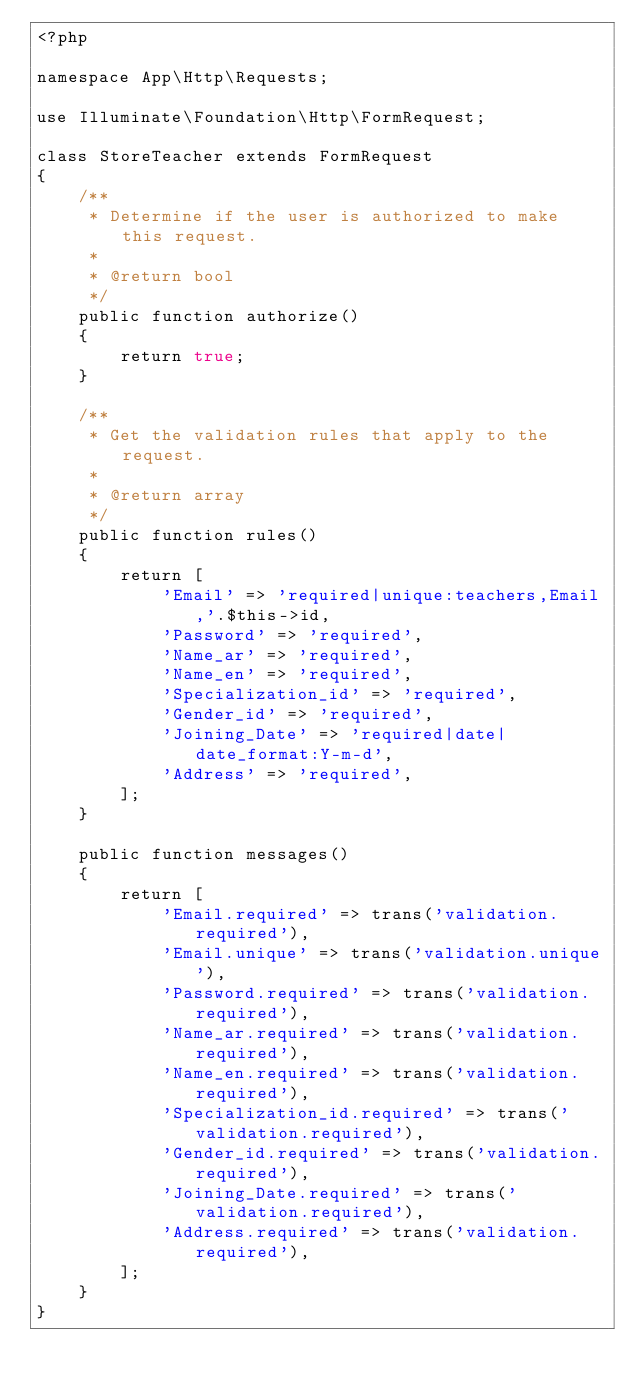Convert code to text. <code><loc_0><loc_0><loc_500><loc_500><_PHP_><?php

namespace App\Http\Requests;

use Illuminate\Foundation\Http\FormRequest;

class StoreTeacher extends FormRequest
{
    /**
     * Determine if the user is authorized to make this request.
     *
     * @return bool
     */
    public function authorize()
    {
        return true;
    }

    /**
     * Get the validation rules that apply to the request.
     *
     * @return array
     */
    public function rules()
    {
        return [
            'Email' => 'required|unique:teachers,Email,'.$this->id,
            'Password' => 'required',
            'Name_ar' => 'required',
            'Name_en' => 'required',
            'Specialization_id' => 'required',
            'Gender_id' => 'required',
            'Joining_Date' => 'required|date|date_format:Y-m-d',
            'Address' => 'required',
        ];
    }

    public function messages()
    {
        return [
            'Email.required' => trans('validation.required'),
            'Email.unique' => trans('validation.unique'),
            'Password.required' => trans('validation.required'),
            'Name_ar.required' => trans('validation.required'),
            'Name_en.required' => trans('validation.required'),
            'Specialization_id.required' => trans('validation.required'),
            'Gender_id.required' => trans('validation.required'),
            'Joining_Date.required' => trans('validation.required'),
            'Address.required' => trans('validation.required'),
        ];
    }
}
</code> 